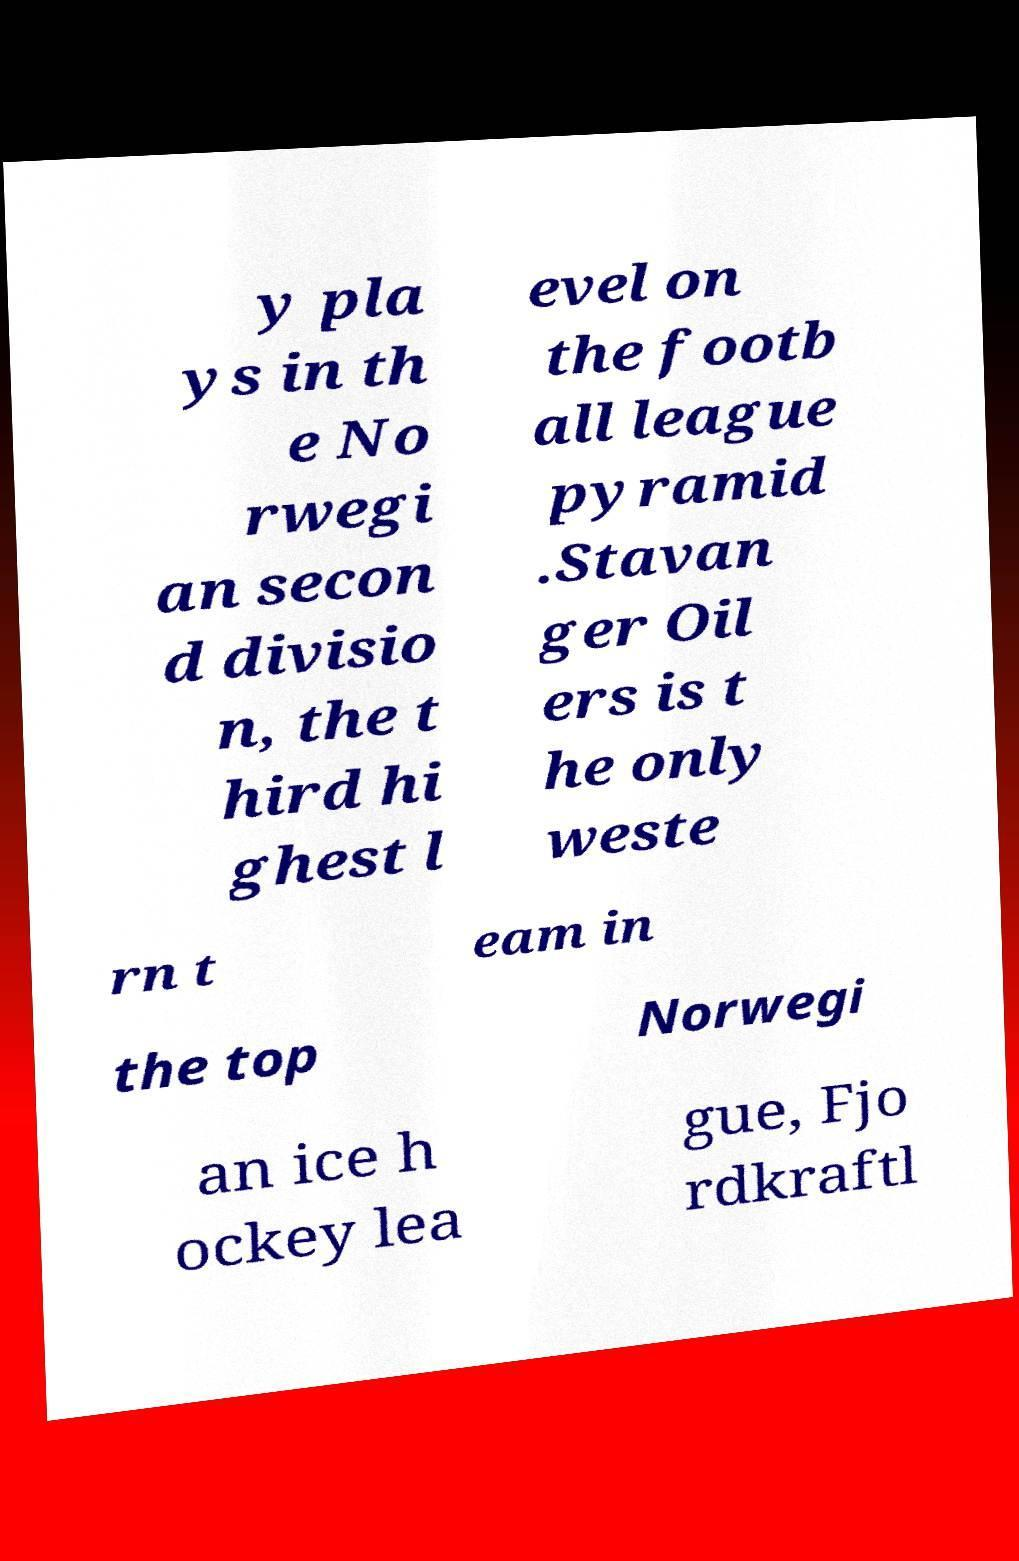Can you read and provide the text displayed in the image?This photo seems to have some interesting text. Can you extract and type it out for me? y pla ys in th e No rwegi an secon d divisio n, the t hird hi ghest l evel on the footb all league pyramid .Stavan ger Oil ers is t he only weste rn t eam in the top Norwegi an ice h ockey lea gue, Fjo rdkraftl 